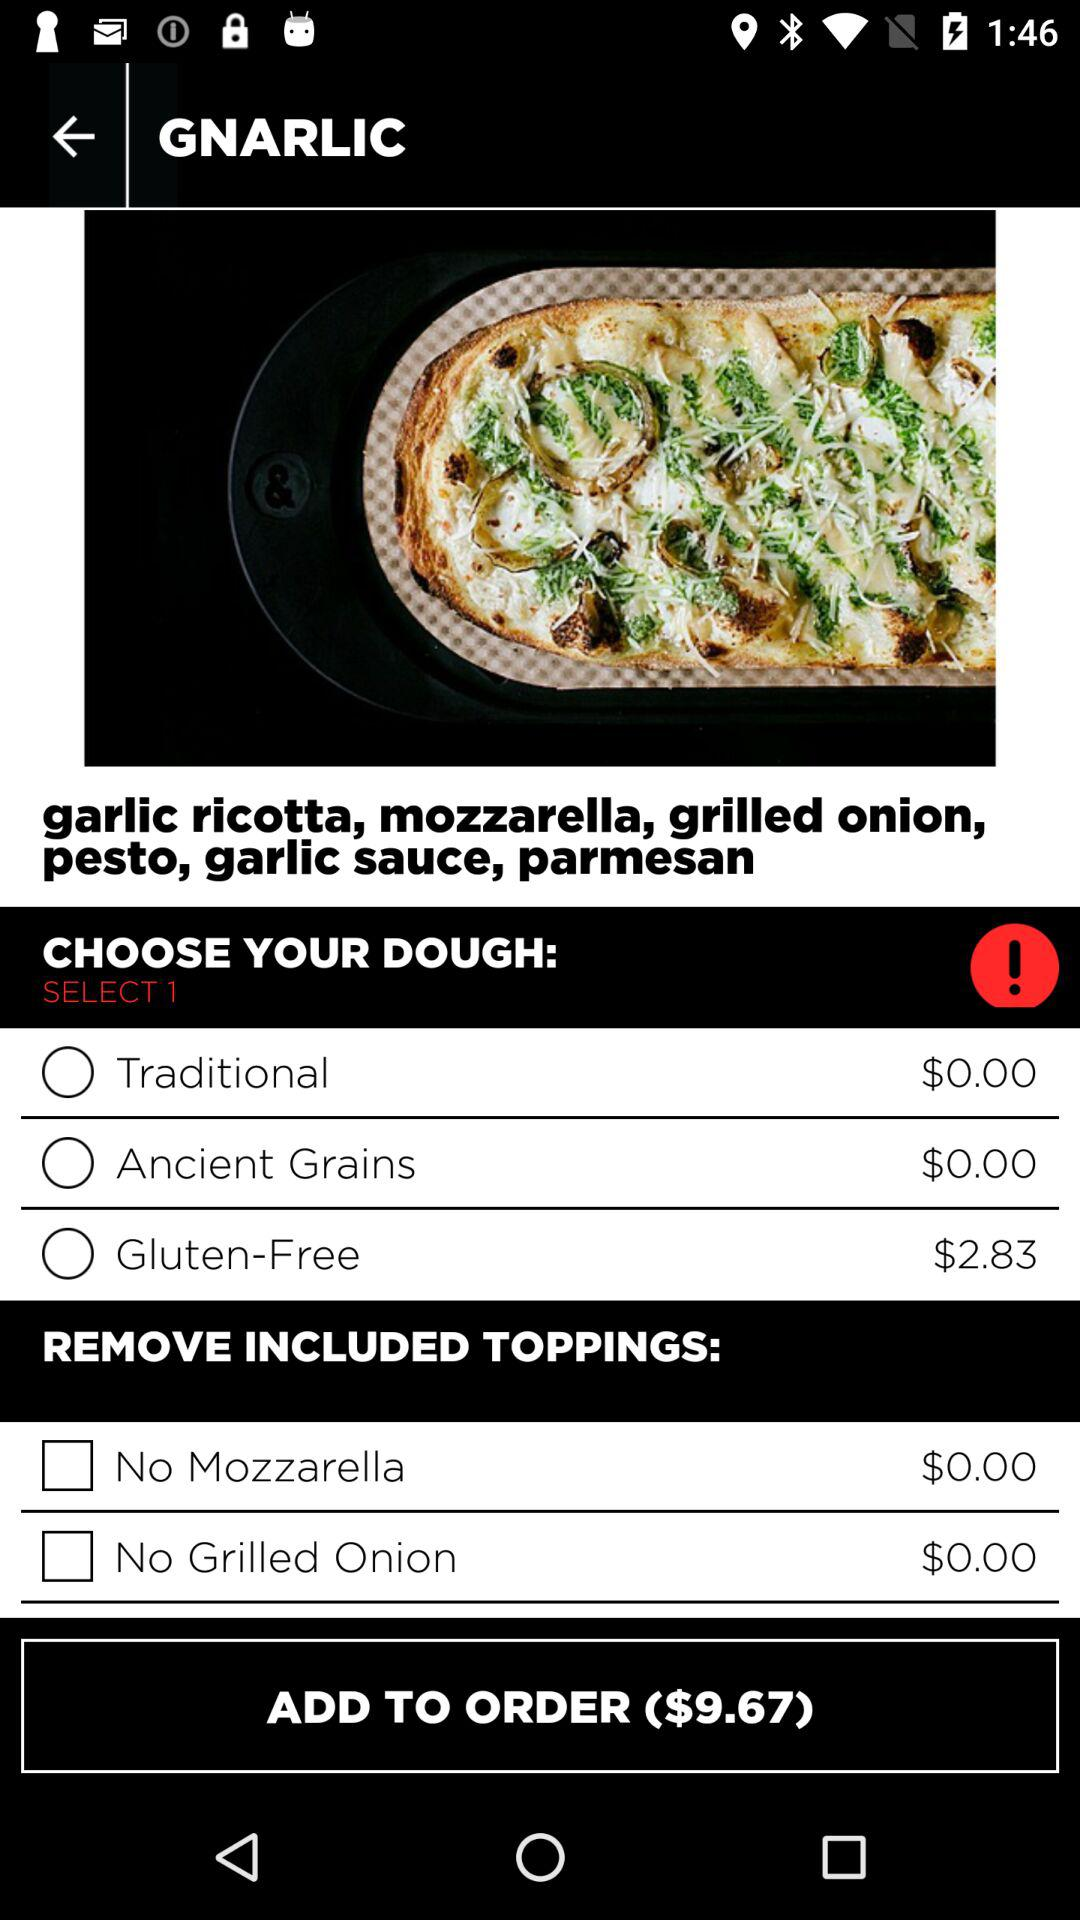What is the price of "Gluten-Free" dough? The price of "Gluten-Free" dough is $2.83. 